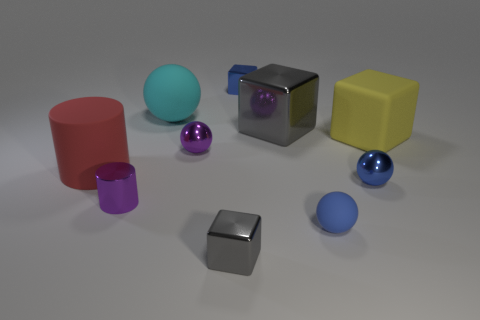How many other large yellow things have the same shape as the yellow rubber thing? Upon examining the image, there appears to be just one large yellow object, which is cubical. There are no other large yellow objects with the same shape in the photograph. 